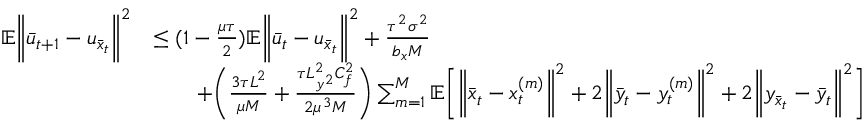Convert formula to latex. <formula><loc_0><loc_0><loc_500><loc_500>\begin{array} { r l } { \mathbb { E } \left \| \bar { u } _ { t + 1 } - u _ { \bar { x } _ { t } } \right \| ^ { 2 } } & { \leq ( 1 - \frac { \mu \tau } { 2 } ) \mathbb { E } \left \| \bar { u } _ { t } - u _ { \bar { x } _ { t } } \right \| ^ { 2 } + \frac { \tau ^ { 2 } \sigma ^ { 2 } } { b _ { x } M } } \\ & { \quad + \left ( \frac { 3 \tau L ^ { 2 } } { \mu M } + \frac { \tau L _ { y ^ { 2 } } ^ { 2 } C _ { f } ^ { 2 } } { 2 \mu ^ { 3 } M } \right ) \sum _ { m = 1 } ^ { M } \mathbb { E } \left [ \left \| \bar { x } _ { t } - x _ { t } ^ { ( m ) } \right \| ^ { 2 } + 2 \left \| \bar { y } _ { t } - y _ { t } ^ { ( m ) } \right \| ^ { 2 } + 2 \left \| y _ { \bar { x } _ { t } } - \bar { y } _ { t } \right \| ^ { 2 } \right ] } \end{array}</formula> 